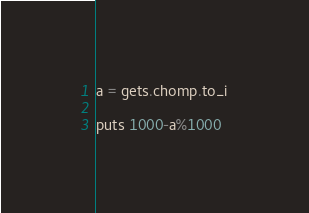<code> <loc_0><loc_0><loc_500><loc_500><_Ruby_>a = gets.chomp.to_i

puts 1000-a%1000</code> 